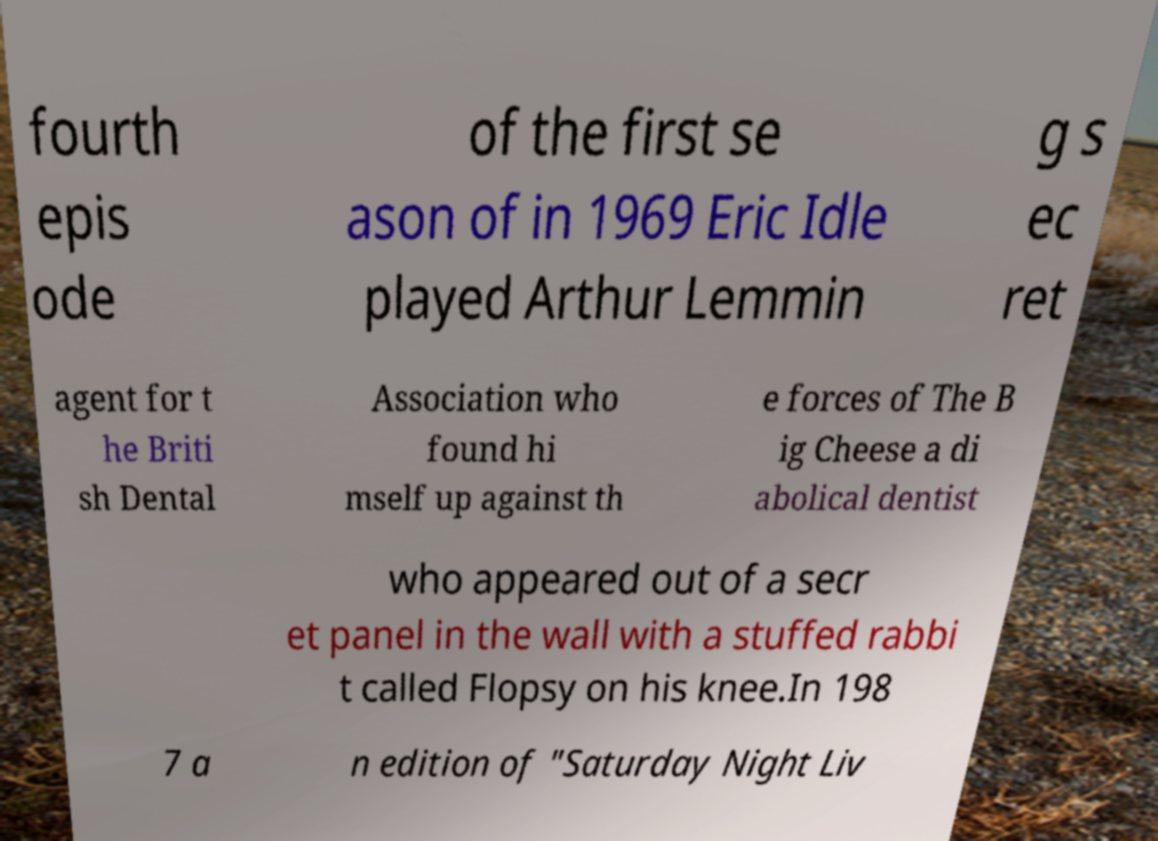Please read and relay the text visible in this image. What does it say? fourth epis ode of the first se ason of in 1969 Eric Idle played Arthur Lemmin g s ec ret agent for t he Briti sh Dental Association who found hi mself up against th e forces of The B ig Cheese a di abolical dentist who appeared out of a secr et panel in the wall with a stuffed rabbi t called Flopsy on his knee.In 198 7 a n edition of "Saturday Night Liv 